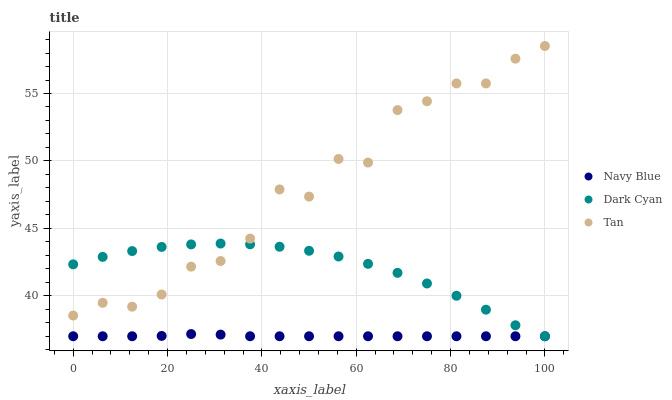Does Navy Blue have the minimum area under the curve?
Answer yes or no. Yes. Does Tan have the maximum area under the curve?
Answer yes or no. Yes. Does Tan have the minimum area under the curve?
Answer yes or no. No. Does Navy Blue have the maximum area under the curve?
Answer yes or no. No. Is Navy Blue the smoothest?
Answer yes or no. Yes. Is Tan the roughest?
Answer yes or no. Yes. Is Tan the smoothest?
Answer yes or no. No. Is Navy Blue the roughest?
Answer yes or no. No. Does Dark Cyan have the lowest value?
Answer yes or no. Yes. Does Tan have the lowest value?
Answer yes or no. No. Does Tan have the highest value?
Answer yes or no. Yes. Does Navy Blue have the highest value?
Answer yes or no. No. Is Navy Blue less than Tan?
Answer yes or no. Yes. Is Tan greater than Navy Blue?
Answer yes or no. Yes. Does Dark Cyan intersect Navy Blue?
Answer yes or no. Yes. Is Dark Cyan less than Navy Blue?
Answer yes or no. No. Is Dark Cyan greater than Navy Blue?
Answer yes or no. No. Does Navy Blue intersect Tan?
Answer yes or no. No. 